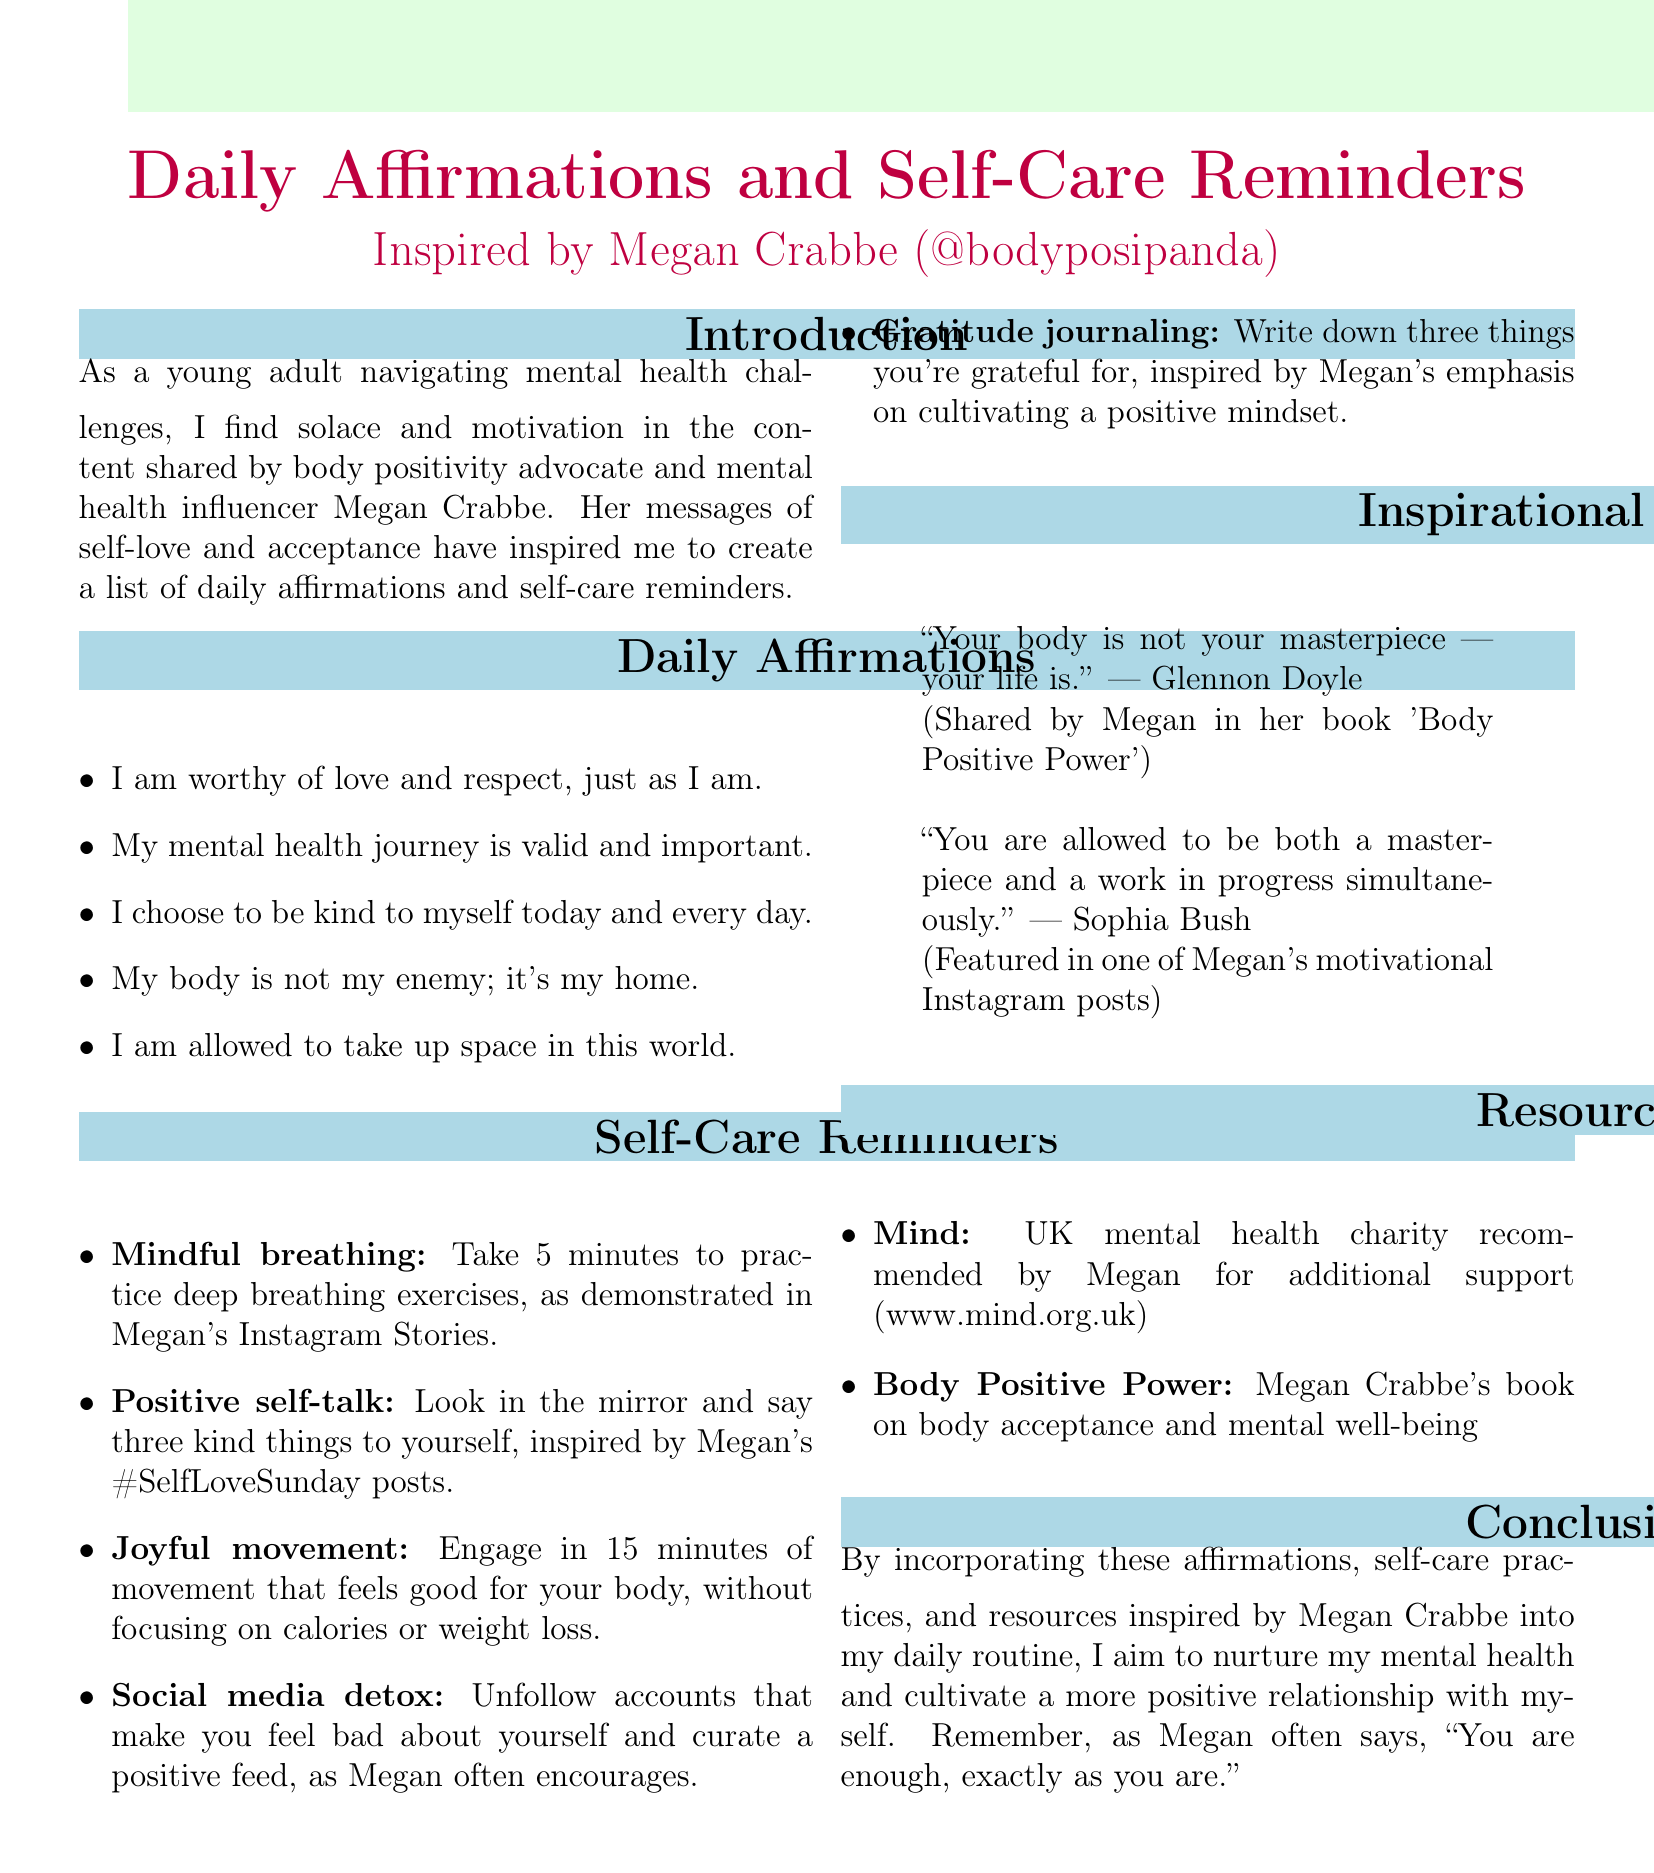What is the title of the memo? The title of the memo summarizes its content, highlighting the themes of daily affirmations and self-care reminders influenced by a specific advocate.
Answer: Daily Affirmations and Self-Care Reminders Inspired by Megan Crabbe (@bodyposipanda) Who is the influencer mentioned in the memo? The influencer is paramount to the theme of the memo, inspiring the creation of affirmations and self-care reminders.
Answer: Megan Crabbe (@bodyposipanda) How many daily affirmations are listed? The total count of affirmations demonstrates the depth of content provided in the memo.
Answer: Five What activity is suggested for mindful breathing? This detail illustrates a specific self-care practice recommended in the document.
Answer: Deep breathing exercises Which charity is recommended for additional support? The mentioned resource provides an avenue for further mental health assistance according to the memo.
Answer: Mind What quote is shared by Glennon Doyle? The quote serves as an inspirational highlight within the context of the affirmations and self-acceptance themes.
Answer: Your body is not your masterpiece — your life is What is emphasized in Megan’s #SelfLoveSunday posts? This element reflects the positive self-talk practices encouraged in the memo, signaling a specific focus on self-love.
Answer: Kind things to yourself What should you write in your gratitude journal? This request specifies the content that the memo encourages for cultivating a positive mindset.
Answer: Three things you're grateful for 